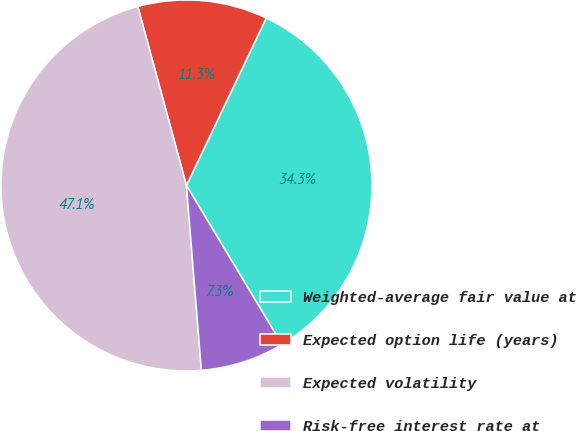<chart> <loc_0><loc_0><loc_500><loc_500><pie_chart><fcel>Weighted-average fair value at<fcel>Expected option life (years)<fcel>Expected volatility<fcel>Risk-free interest rate at<nl><fcel>34.31%<fcel>11.3%<fcel>47.06%<fcel>7.33%<nl></chart> 